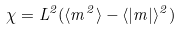<formula> <loc_0><loc_0><loc_500><loc_500>\chi = L ^ { 2 } ( \langle m ^ { 2 } \rangle - \langle | m | \rangle ^ { 2 } )</formula> 